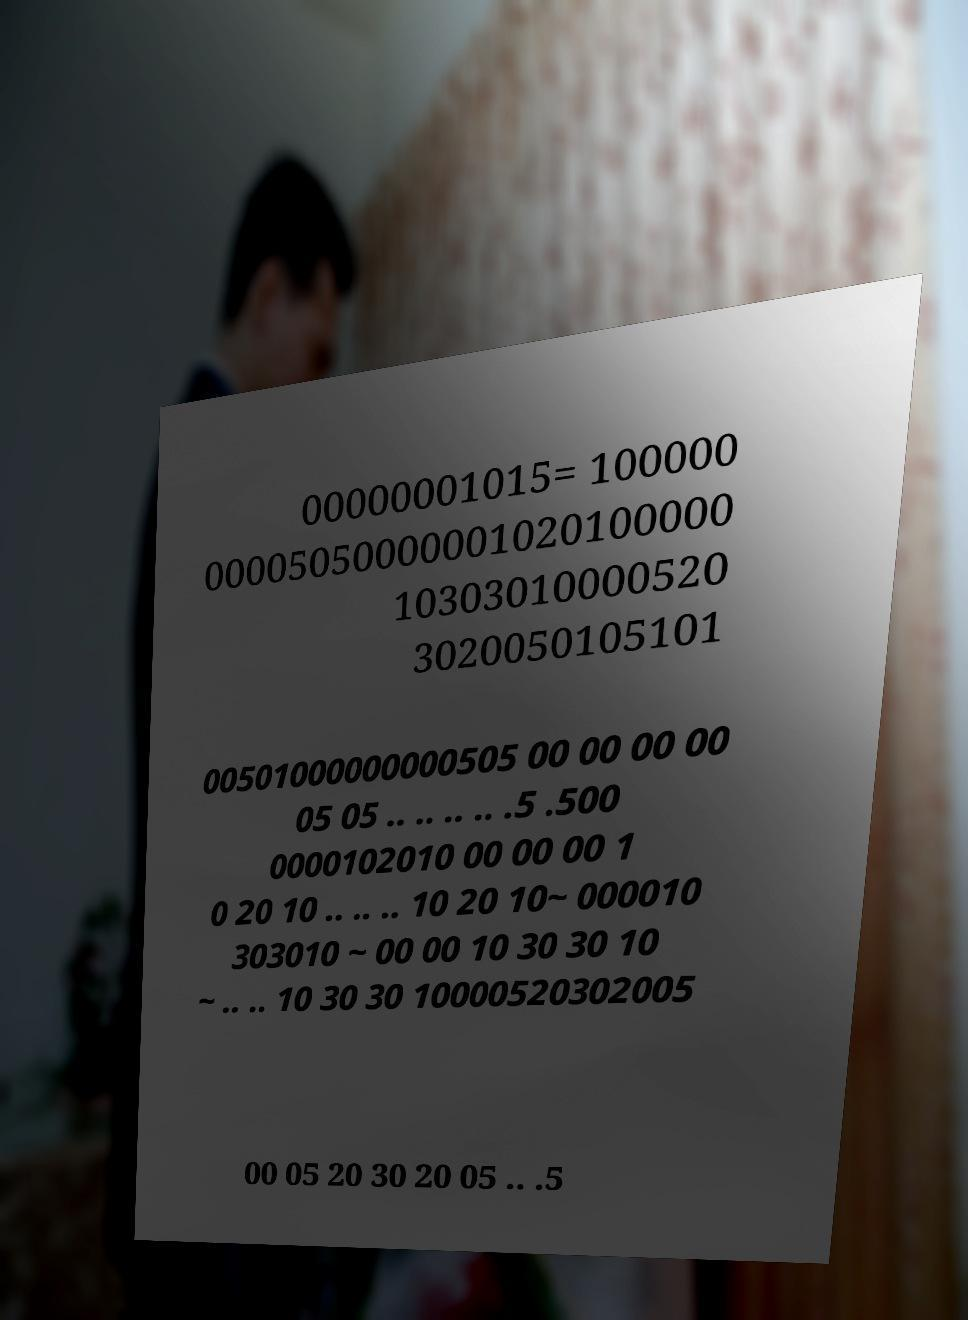What messages or text are displayed in this image? I need them in a readable, typed format. 00000001015= 100000 00005050000001020100000 10303010000520 3020050105101 00501000000000505 00 00 00 00 05 05 .. .. .. .. .5 .500 0000102010 00 00 00 1 0 20 10 .. .. .. 10 20 10~ 000010 303010 ~ 00 00 10 30 30 10 ~ .. .. 10 30 30 10000520302005 00 05 20 30 20 05 .. .5 